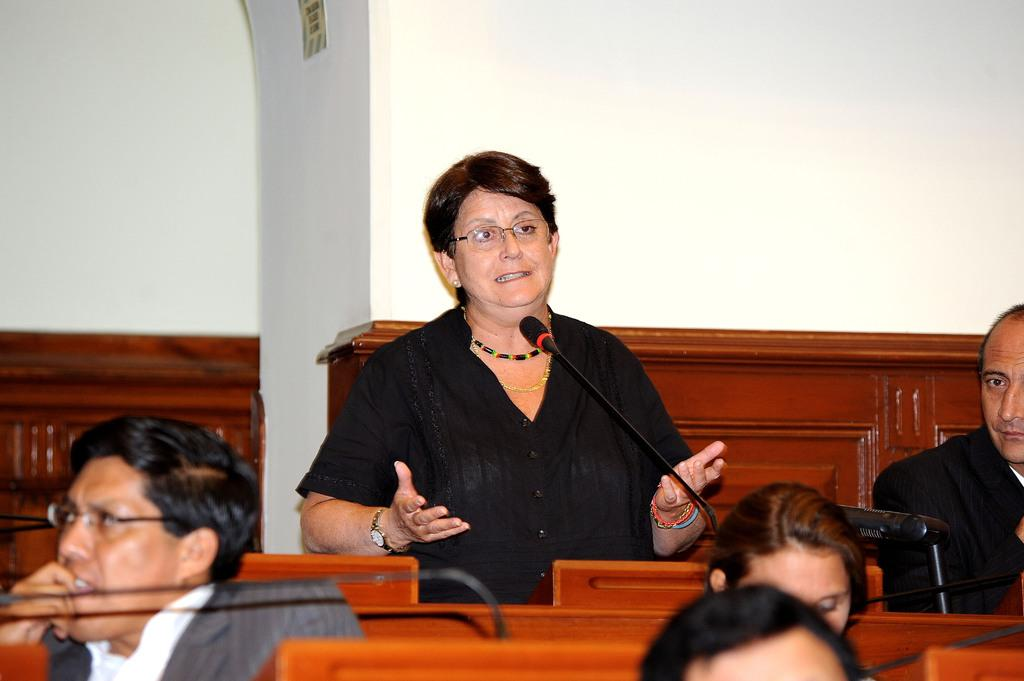What is the woman in the image doing? The woman is standing and speaking in the image. How many people are sitting in the image? There are four people sitting in the image. What can be seen in the background of the image? There is a plain white wall in the background of the image. What objects are present to aid in the speaking process? Microphones (mikes) are visible in the image. What type of vegetable is the woman holding in the image? There is no vegetable present in the image; the woman is standing and speaking. 